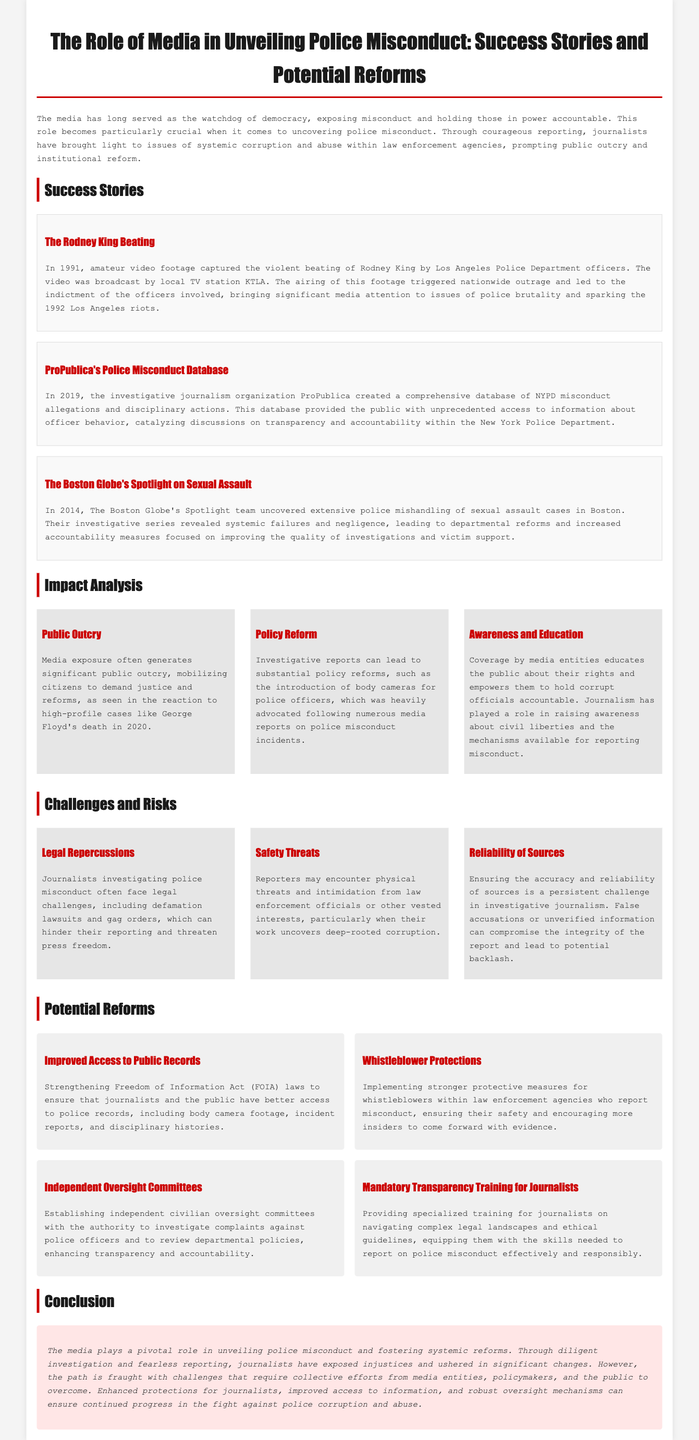what year was the Rodney King beating captured? The beating of Rodney King was captured in 1991, as stated in the success story section.
Answer: 1991 who created the police misconduct database? The database of NYPD misconduct allegations was created by ProPublica, which is mentioned in the success stories.
Answer: ProPublica what event triggered nationwide outrage and led to the 1992 Los Angeles riots? The event that triggered nationwide outrage was the violent beating of Rodney King by police officers.
Answer: Rodney King beating how many success stories are presented in the document? There are three specific success stories highlighted in the document regarding media's role in police misconduct.
Answer: Three what type of training is suggested for journalists? The document suggests providing mandatory transparency training for journalists to enhance their reporting on police misconduct.
Answer: Mandatory transparency training what main issue was uncovered by The Boston Globe in 2014? The Boston Globe's Spotlight team uncovered extensive police mishandling of sexual assault cases in Boston in 2014.
Answer: Sexual assault cases mishandling what challenges do journalists face when investigating police misconduct? Journalists investigating police misconduct face challenges such as legal repercussions, safety threats, and issues regarding the reliability of sources.
Answer: Legal repercussions, safety threats, reliability of sources what reform aims to enhance transparency and accountability within law enforcement? Establishing independent civilian oversight committees is proposed as a reform to enhance transparency and accountability within law enforcement.
Answer: Independent oversight committees 